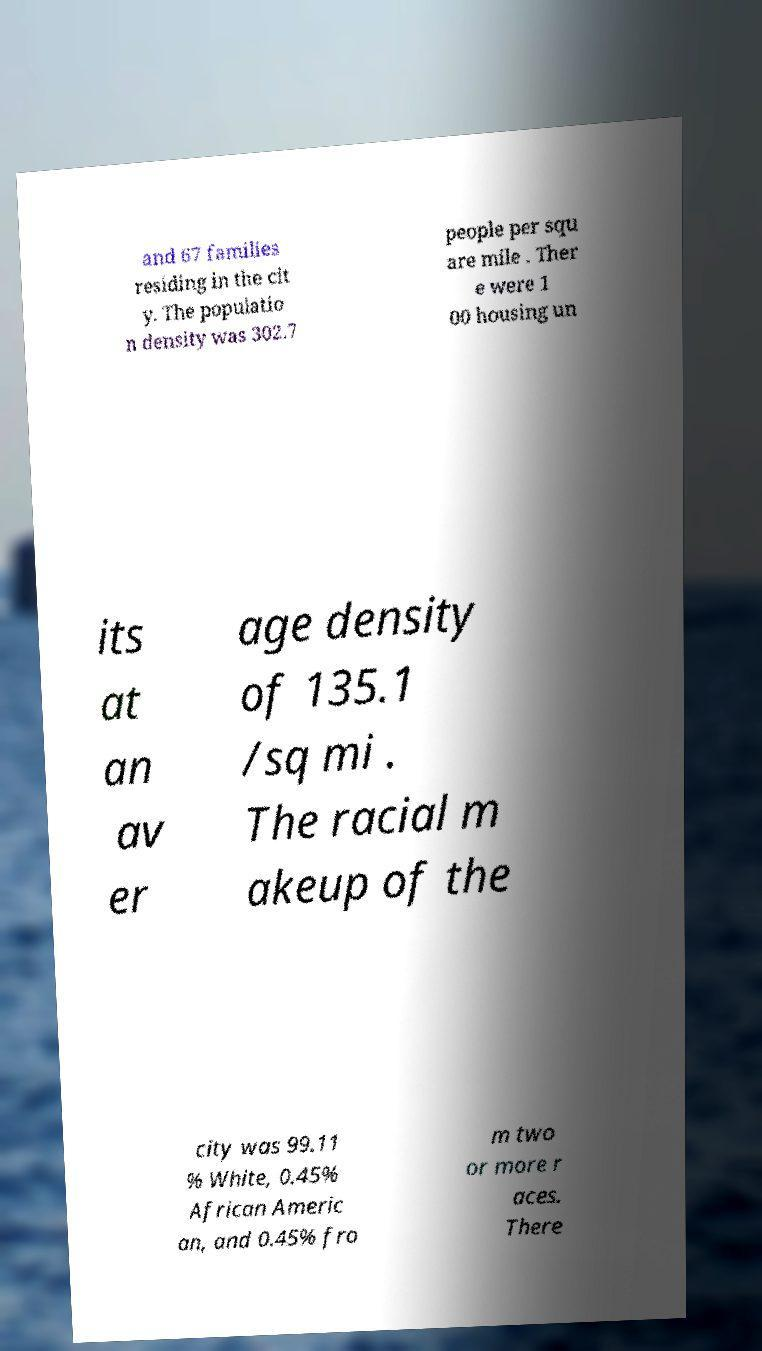Could you extract and type out the text from this image? and 67 families residing in the cit y. The populatio n density was 302.7 people per squ are mile . Ther e were 1 00 housing un its at an av er age density of 135.1 /sq mi . The racial m akeup of the city was 99.11 % White, 0.45% African Americ an, and 0.45% fro m two or more r aces. There 